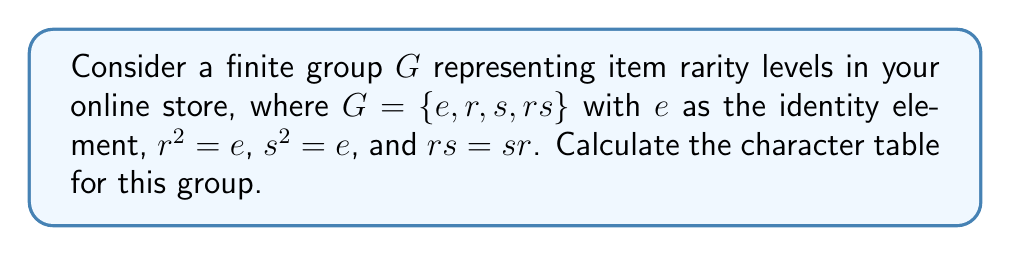Provide a solution to this math problem. To calculate the character table for the group $G$, we'll follow these steps:

1) First, identify the conjugacy classes of $G$:
   Since $G$ is abelian, each element forms its own conjugacy class.
   Classes: $\{e\}$, $\{r\}$, $\{s\}$, $\{rs\}$

2) The number of irreducible representations equals the number of conjugacy classes, so we have 4 irreducible representations.

3) For an abelian group, all irreducible representations are 1-dimensional.

4) The character values for each representation are:

   a) Trivial representation $\chi_1$: All elements map to 1.
   
   b) $\chi_2$: $e \mapsto 1$, $r \mapsto -1$, $s \mapsto 1$, $rs \mapsto -1$
   
   c) $\chi_3$: $e \mapsto 1$, $r \mapsto 1$, $s \mapsto -1$, $rs \mapsto -1$
   
   d) $\chi_4$: $e \mapsto 1$, $r \mapsto -1$, $s \mapsto -1$, $rs \mapsto 1$

5) Construct the character table:

   $$
   \begin{array}{c|cccc}
   G & e & r & s & rs \\
   \hline
   \chi_1 & 1 & 1 & 1 & 1 \\
   \chi_2 & 1 & -1 & 1 & -1 \\
   \chi_3 & 1 & 1 & -1 & -1 \\
   \chi_4 & 1 & -1 & -1 & 1
   \end{array}
   $$

This character table represents how each irreducible representation acts on the elements of the group, which could correspond to different ways of categorizing item rarity in the online store.
Answer: $$
\begin{array}{c|cccc}
G & e & r & s & rs \\
\hline
\chi_1 & 1 & 1 & 1 & 1 \\
\chi_2 & 1 & -1 & 1 & -1 \\
\chi_3 & 1 & 1 & -1 & -1 \\
\chi_4 & 1 & -1 & -1 & 1
\end{array}
$$ 